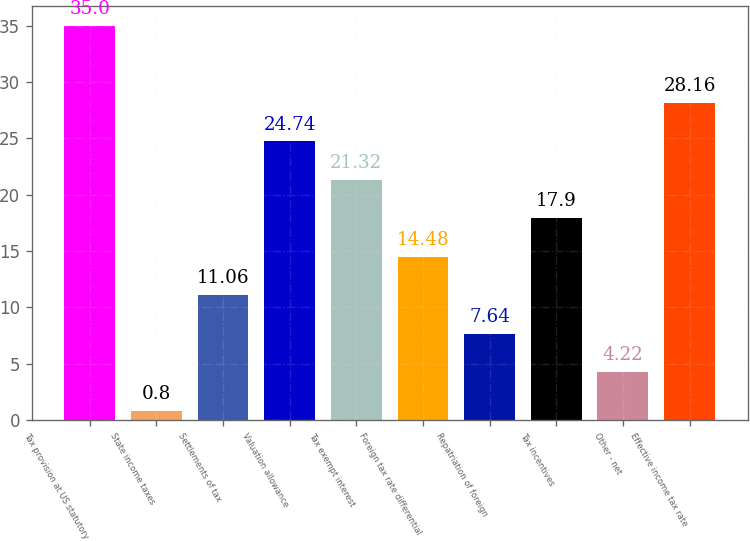Convert chart to OTSL. <chart><loc_0><loc_0><loc_500><loc_500><bar_chart><fcel>Tax provision at US statutory<fcel>State income taxes<fcel>Settlements of tax<fcel>Valuation allowance<fcel>Tax exempt interest<fcel>Foreign tax rate differential<fcel>Repatriation of foreign<fcel>Tax incentives<fcel>Other - net<fcel>Effective income tax rate<nl><fcel>35<fcel>0.8<fcel>11.06<fcel>24.74<fcel>21.32<fcel>14.48<fcel>7.64<fcel>17.9<fcel>4.22<fcel>28.16<nl></chart> 